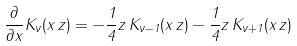<formula> <loc_0><loc_0><loc_500><loc_500>\frac { \partial } { \partial x } K _ { \nu } ( x { \, } z ) = - \frac { 1 } { 4 } z { \, } K _ { \nu - 1 } ( x { \, } z ) - \frac { 1 } { 4 } z { \, } K _ { \nu + 1 } ( x { \, } z )</formula> 